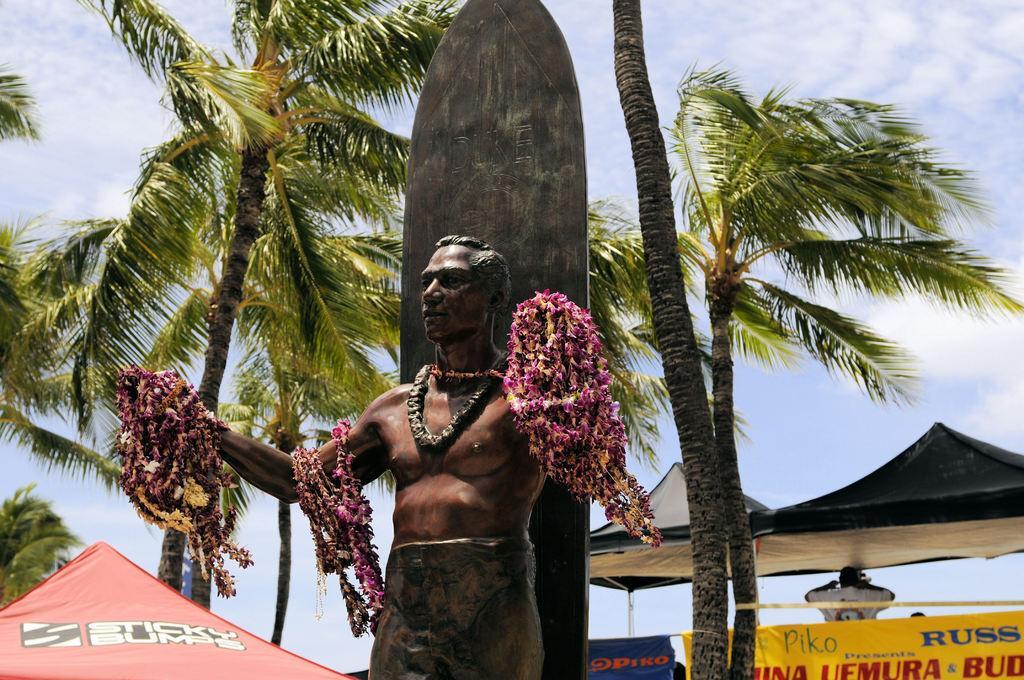In one or two sentences, can you explain what this image depicts? There is a sculpture of a man and there are many garlands on the sculpture, behind the sculpture there are few tents and banners and in between them there are very tall trees. 